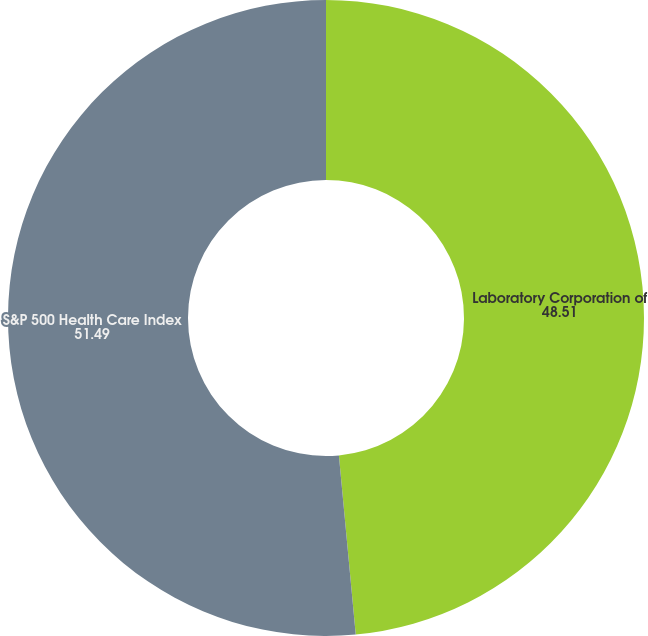Convert chart. <chart><loc_0><loc_0><loc_500><loc_500><pie_chart><fcel>Laboratory Corporation of<fcel>S&P 500 Health Care Index<nl><fcel>48.51%<fcel>51.49%<nl></chart> 